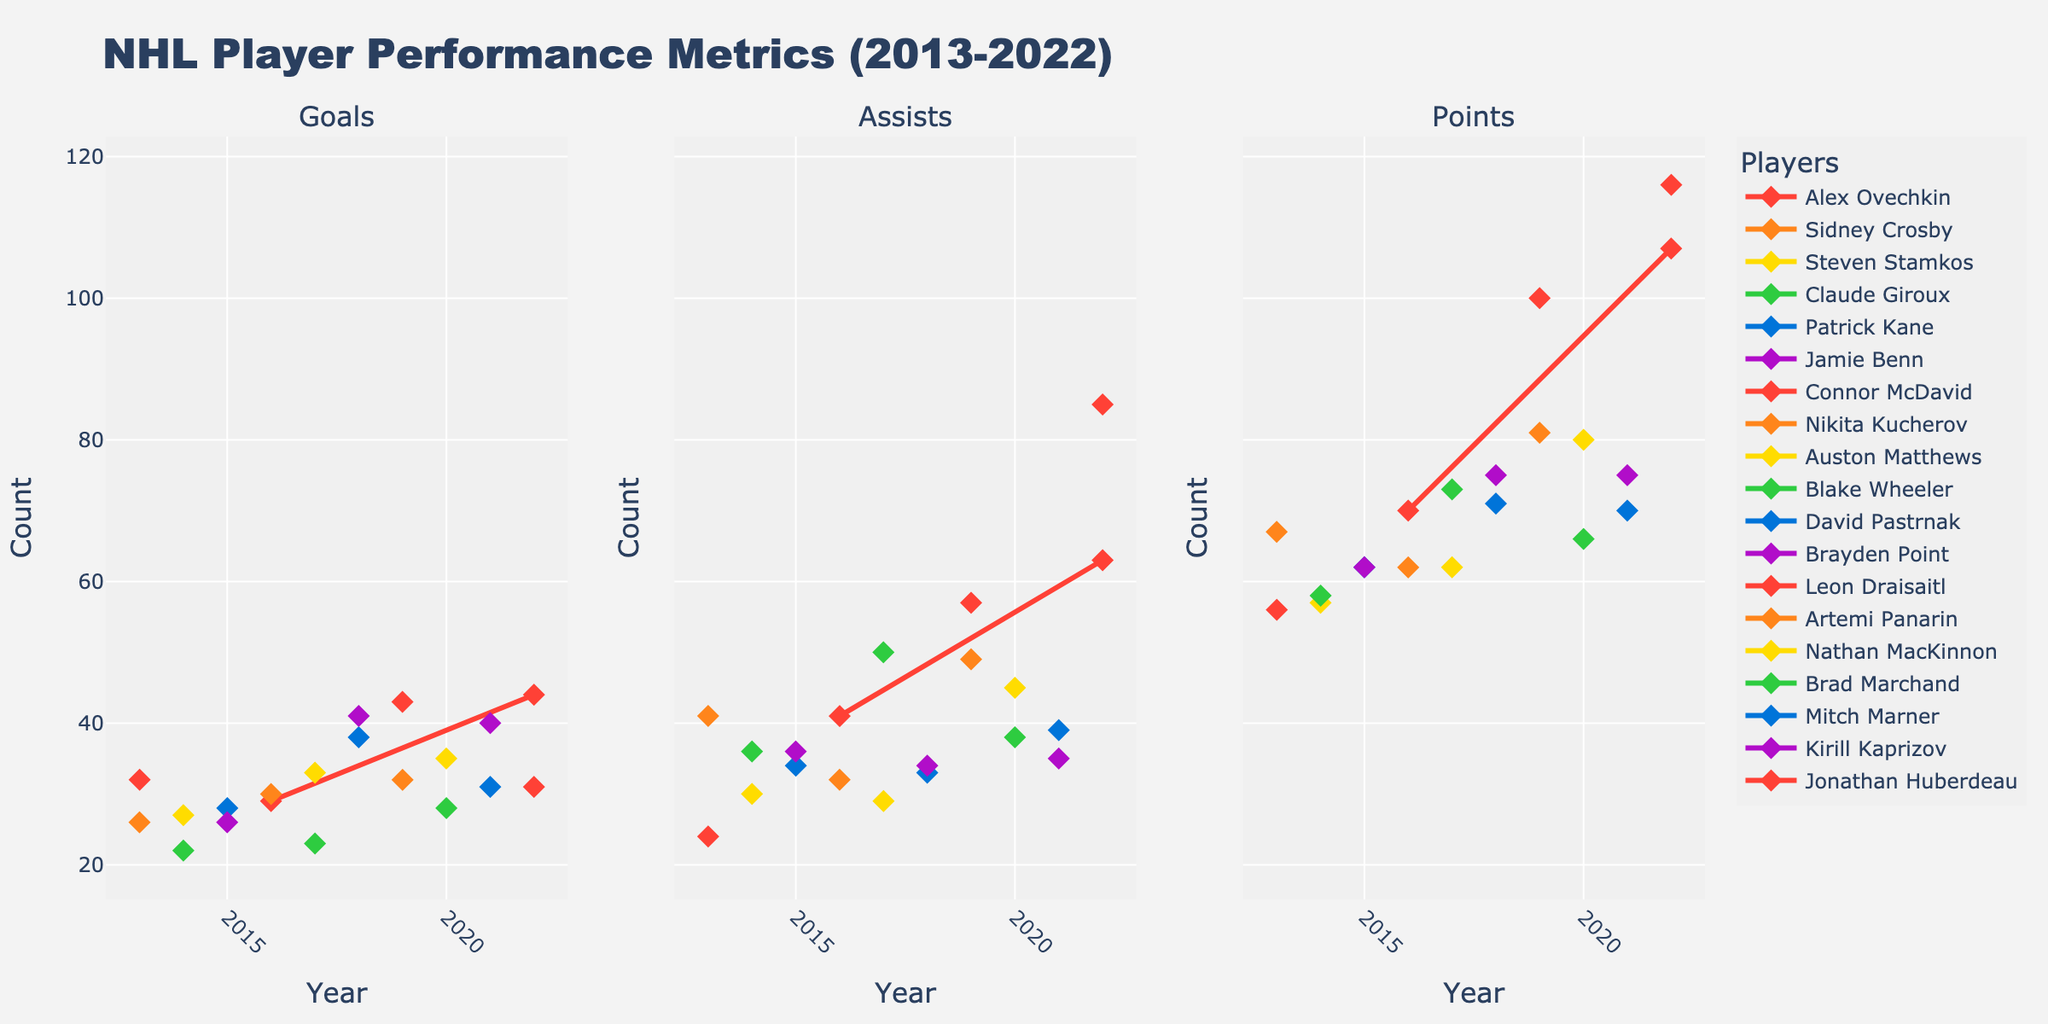What's the title of the figure? The title of the figure is displayed prominently at the top. It reads "NHL Player Performance Metrics (2013-2022)"
Answer: NHL Player Performance Metrics (2013-2022) Which player had the highest number of goals in 2019? Looking at the "Goals" subplot for the year 2019, the marker at the highest point corresponds to Leon Draisaitl.
Answer: Leon Draisaitl What are the three subplots titled? The subplot titles are displayed at the top of each subplot. They are "Goals", "Assists", and "Points".
Answer: Goals, Assists, Points Who had more assists in 2022, Connor McDavid or Jonathan Huberdeau? Refer to the "Assists" subplot and check the points for McDavid and Huberdeau for the year 2022. Huberdeau had more assists.
Answer: Jonathan Huberdeau How many players have data points in the figure? The legend on the right side lists all the players. Counting the names, there are 18 players.
Answer: 18 Which player has the highest point increased between their earliest and latest recorded year? Calculate the difference for each player's points from their earliest to latest year represented in the "Points" subplot. Jonathan Huberdeau increased from 116 in 2022 to none in the previous years included.
Answer: Jonathan Huberdeau What is the average number of assists scored by Sidney Crosby in 2013 and Armes Tanier in 2022? To find the average: (41 assists by Crosby in 2013 and 63 assists by McDavid in 2022). Sum these values: 41 + 63 = 104. Then, divide by 2 to get the average: 104/2 = 52
Answer: 52 Who had higher total points in 2020, Nathan MacKinnon or Brad Marchand? Check the "Points" subplot for 2020, where MacKinnon had 80 points and Marchand had 66. MacKinnon had higher points.
Answer: Nathan MacKinnon Which year saw the highest number of goals by David Pastrnak? In the "Goals" subplot, find the year with the highest point for David Pastrnak, which is 2018 with 38 goals.
Answer: 2018 Across all players and years, who achieved the highest number of assists and in which year? Look at the "Assists" subplot to find the highest point, which is 85 assists by Jonathan Huberdeau in 2022.
Answer: Jonathan Huberdeau, 2022 